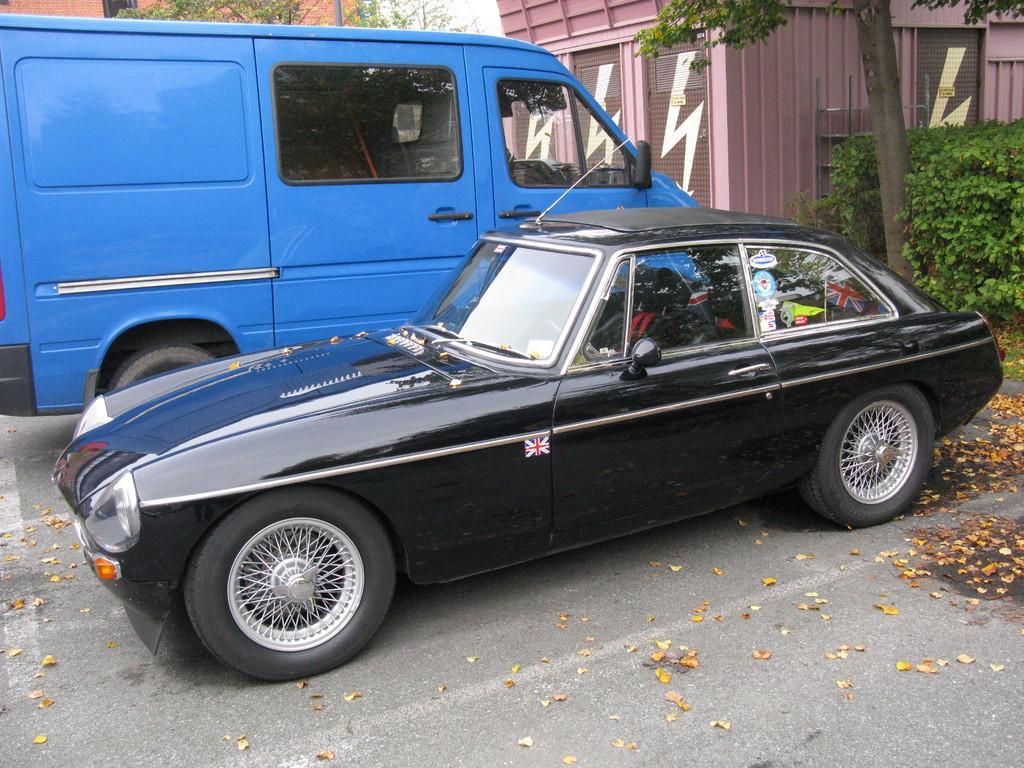Please provide a concise description of this image. In this image I can see a black car and a blue van. In the background I can see bushes, few trees and few buildings. In the front I can see number of leaves on the road. 